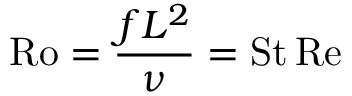<formula> <loc_0><loc_0><loc_500><loc_500>R o = { \frac { f L ^ { 2 } } { \nu } } = S t \, R e</formula> 